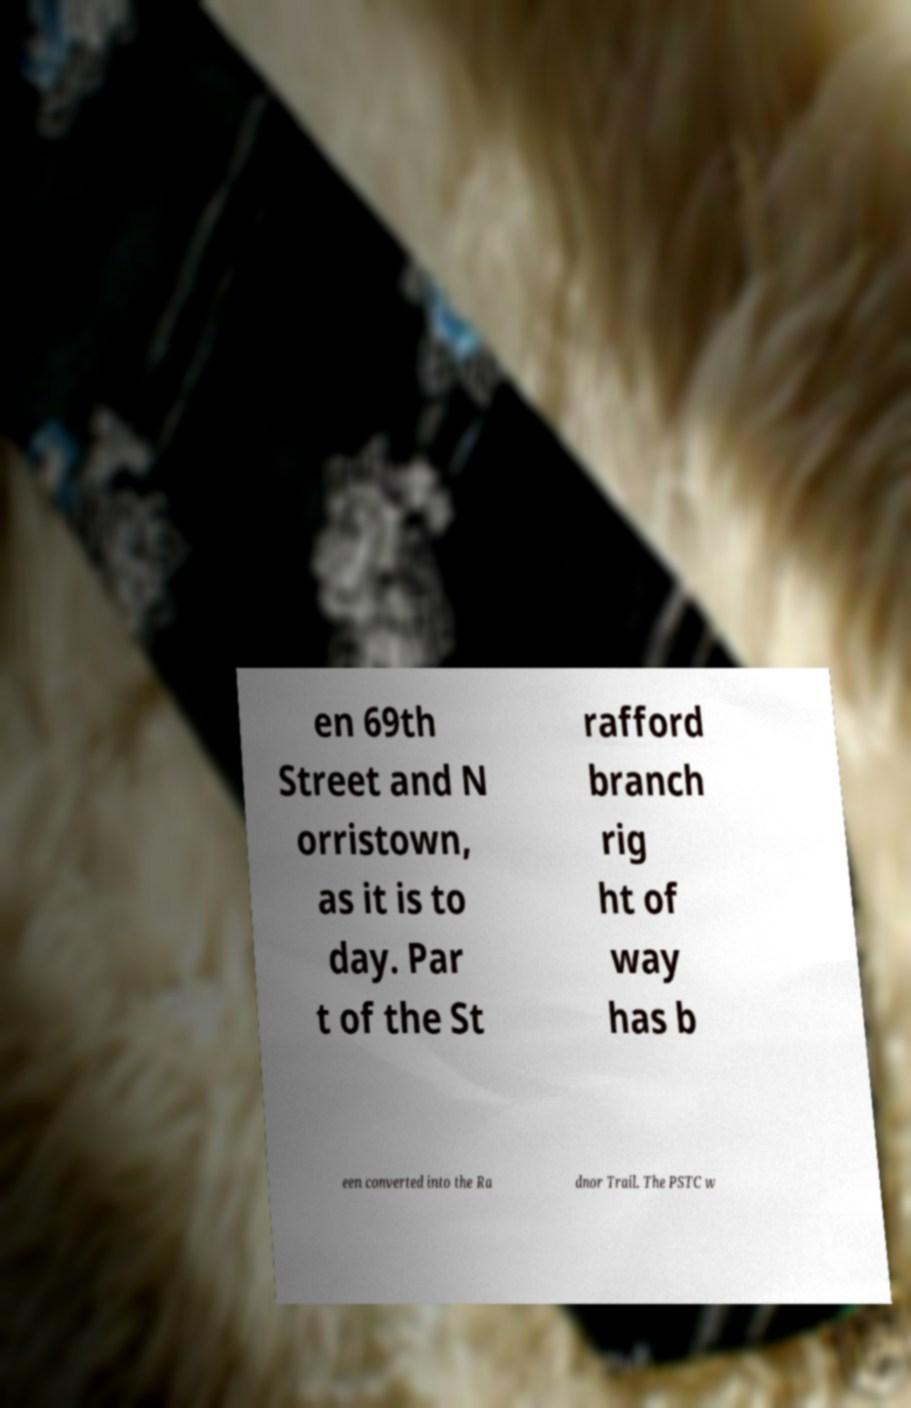Please identify and transcribe the text found in this image. en 69th Street and N orristown, as it is to day. Par t of the St rafford branch rig ht of way has b een converted into the Ra dnor Trail. The PSTC w 